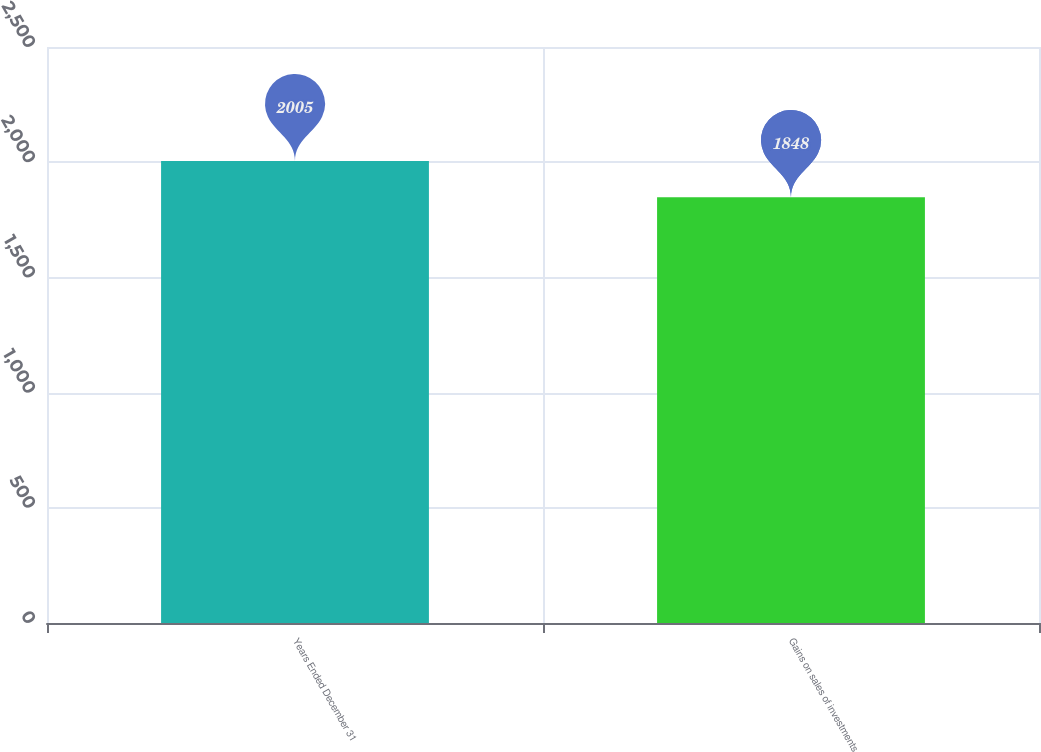Convert chart. <chart><loc_0><loc_0><loc_500><loc_500><bar_chart><fcel>Years Ended December 31<fcel>Gains on sales of investments<nl><fcel>2005<fcel>1848<nl></chart> 